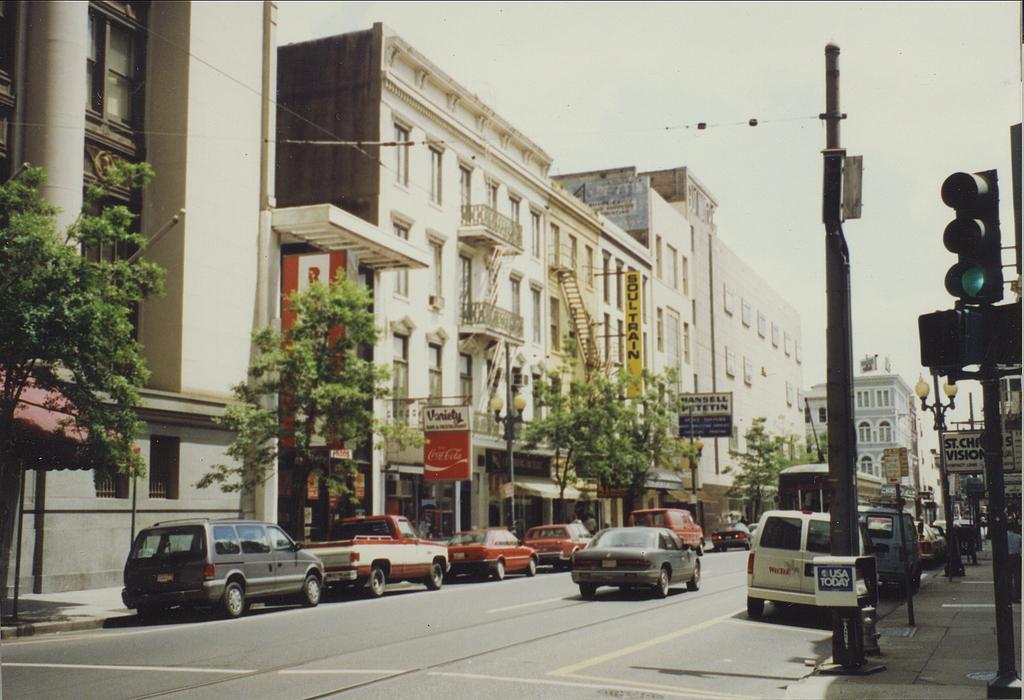Please provide a concise description of this image. Here there are vehicles on the road, here there are buildings with the windows, here there are trees, this is signal and a sky. 